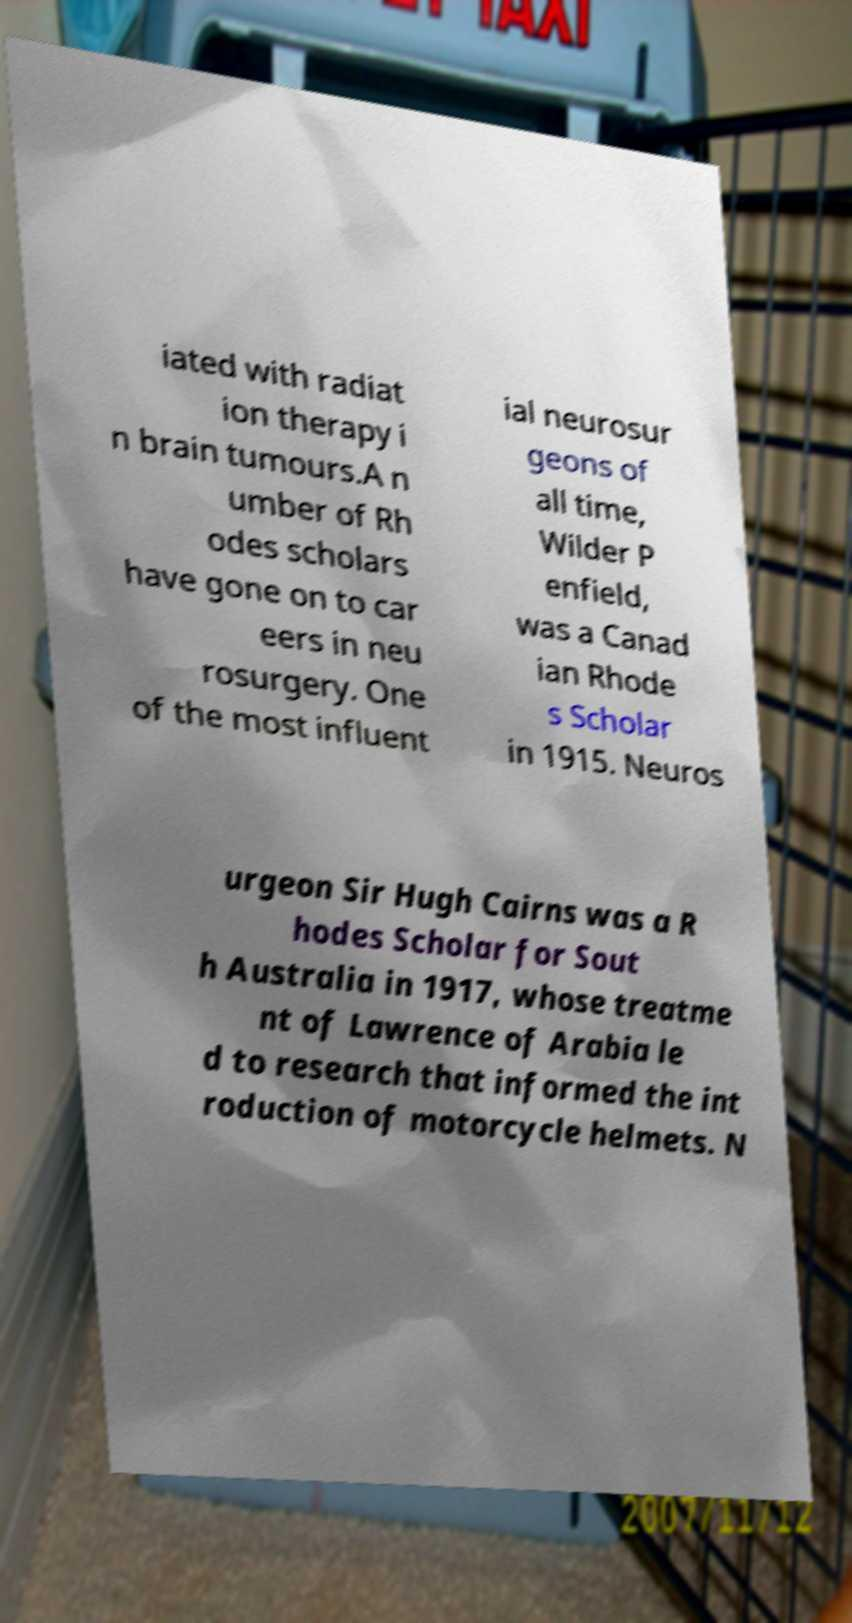Could you assist in decoding the text presented in this image and type it out clearly? iated with radiat ion therapy i n brain tumours.A n umber of Rh odes scholars have gone on to car eers in neu rosurgery. One of the most influent ial neurosur geons of all time, Wilder P enfield, was a Canad ian Rhode s Scholar in 1915. Neuros urgeon Sir Hugh Cairns was a R hodes Scholar for Sout h Australia in 1917, whose treatme nt of Lawrence of Arabia le d to research that informed the int roduction of motorcycle helmets. N 